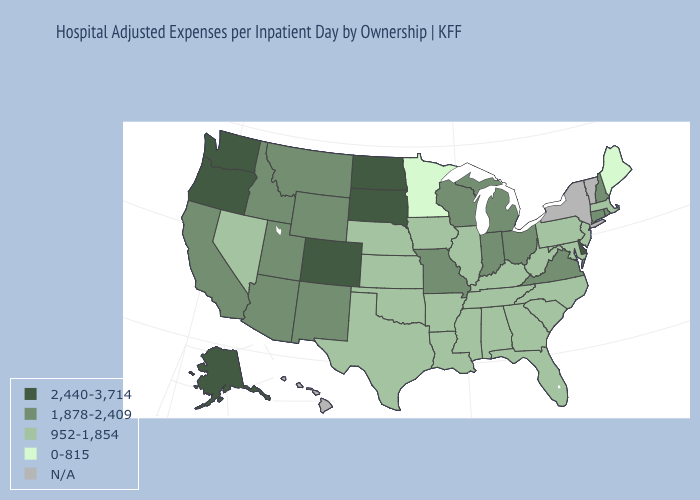What is the value of New Hampshire?
Concise answer only. 1,878-2,409. Name the states that have a value in the range N/A?
Give a very brief answer. Hawaii, New York, Vermont. What is the value of Louisiana?
Short answer required. 952-1,854. Name the states that have a value in the range 1,878-2,409?
Keep it brief. Arizona, California, Connecticut, Idaho, Indiana, Michigan, Missouri, Montana, New Hampshire, New Mexico, Ohio, Rhode Island, Utah, Virginia, Wisconsin, Wyoming. Name the states that have a value in the range 1,878-2,409?
Write a very short answer. Arizona, California, Connecticut, Idaho, Indiana, Michigan, Missouri, Montana, New Hampshire, New Mexico, Ohio, Rhode Island, Utah, Virginia, Wisconsin, Wyoming. Name the states that have a value in the range N/A?
Answer briefly. Hawaii, New York, Vermont. Does the map have missing data?
Answer briefly. Yes. Name the states that have a value in the range 1,878-2,409?
Write a very short answer. Arizona, California, Connecticut, Idaho, Indiana, Michigan, Missouri, Montana, New Hampshire, New Mexico, Ohio, Rhode Island, Utah, Virginia, Wisconsin, Wyoming. What is the value of Minnesota?
Short answer required. 0-815. What is the value of Alaska?
Be succinct. 2,440-3,714. Does Minnesota have the lowest value in the USA?
Concise answer only. Yes. Among the states that border West Virginia , which have the lowest value?
Keep it brief. Kentucky, Maryland, Pennsylvania. 